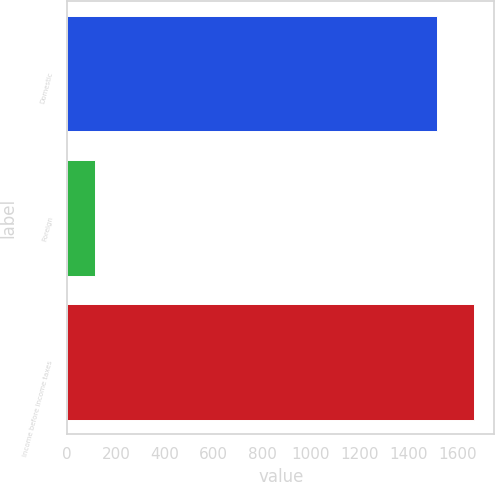<chart> <loc_0><loc_0><loc_500><loc_500><bar_chart><fcel>Domestic<fcel>Foreign<fcel>Income before income taxes<nl><fcel>1517<fcel>114<fcel>1668.7<nl></chart> 